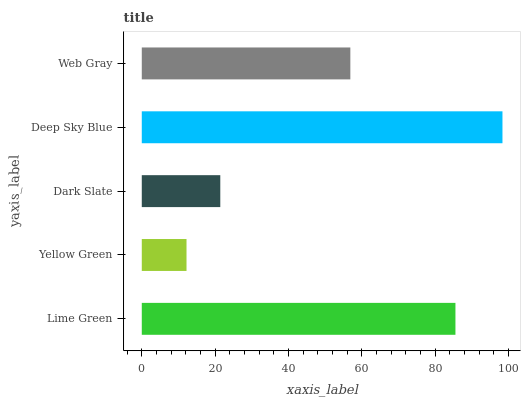Is Yellow Green the minimum?
Answer yes or no. Yes. Is Deep Sky Blue the maximum?
Answer yes or no. Yes. Is Dark Slate the minimum?
Answer yes or no. No. Is Dark Slate the maximum?
Answer yes or no. No. Is Dark Slate greater than Yellow Green?
Answer yes or no. Yes. Is Yellow Green less than Dark Slate?
Answer yes or no. Yes. Is Yellow Green greater than Dark Slate?
Answer yes or no. No. Is Dark Slate less than Yellow Green?
Answer yes or no. No. Is Web Gray the high median?
Answer yes or no. Yes. Is Web Gray the low median?
Answer yes or no. Yes. Is Dark Slate the high median?
Answer yes or no. No. Is Lime Green the low median?
Answer yes or no. No. 